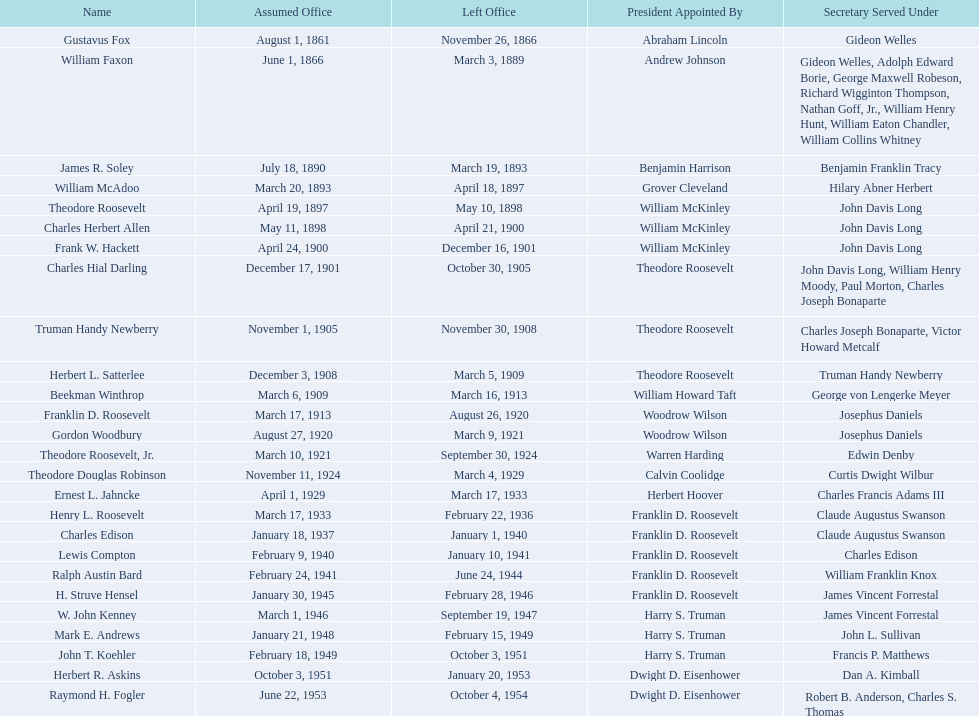Who were all the assistant secretaries of the navy? Gustavus Fox, William Faxon, James R. Soley, William McAdoo, Theodore Roosevelt, Charles Herbert Allen, Frank W. Hackett, Charles Hial Darling, Truman Handy Newberry, Herbert L. Satterlee, Beekman Winthrop, Franklin D. Roosevelt, Gordon Woodbury, Theodore Roosevelt, Jr., Theodore Douglas Robinson, Ernest L. Jahncke, Henry L. Roosevelt, Charles Edison, Lewis Compton, Ralph Austin Bard, H. Struve Hensel, W. John Kenney, Mark E. Andrews, John T. Koehler, Herbert R. Askins, Raymond H. Fogler. What are the various dates they finished their term in office? November 26, 1866, March 3, 1889, March 19, 1893, April 18, 1897, May 10, 1898, April 21, 1900, December 16, 1901, October 30, 1905, November 30, 1908, March 5, 1909, March 16, 1913, August 26, 1920, March 9, 1921, September 30, 1924, March 4, 1929, March 17, 1933, February 22, 1936, January 1, 1940, January 10, 1941, June 24, 1944, February 28, 1946, September 19, 1947, February 15, 1949, October 3, 1951, January 20, 1953, October 4, 1954. Of these dates, which was the date raymond h. fogler ended his term? October 4, 1954. Who were all the assistant secretaries of the navy? Gustavus Fox, William Faxon, James R. Soley, William McAdoo, Theodore Roosevelt, Charles Herbert Allen, Frank W. Hackett, Charles Hial Darling, Truman Handy Newberry, Herbert L. Satterlee, Beekman Winthrop, Franklin D. Roosevelt, Gordon Woodbury, Theodore Roosevelt, Jr., Theodore Douglas Robinson, Ernest L. Jahncke, Henry L. Roosevelt, Charles Edison, Lewis Compton, Ralph Austin Bard, H. Struve Hensel, W. John Kenney, Mark E. Andrews, John T. Koehler, Herbert R. Askins, Raymond H. Fogler. What are the various dates they exited office? November 26, 1866, March 3, 1889, March 19, 1893, April 18, 1897, May 10, 1898, April 21, 1900, December 16, 1901, October 30, 1905, November 30, 1908, March 5, 1909, March 16, 1913, August 26, 1920, March 9, 1921, September 30, 1924, March 4, 1929, March 17, 1933, February 22, 1936, January 1, 1940, January 10, 1941, June 24, 1944, February 28, 1946, September 19, 1947, February 15, 1949, October 3, 1951, January 20, 1953, October 4, 1954. Of these dates, which was the date raymond h. fogler stepped down? October 4, 1954. 